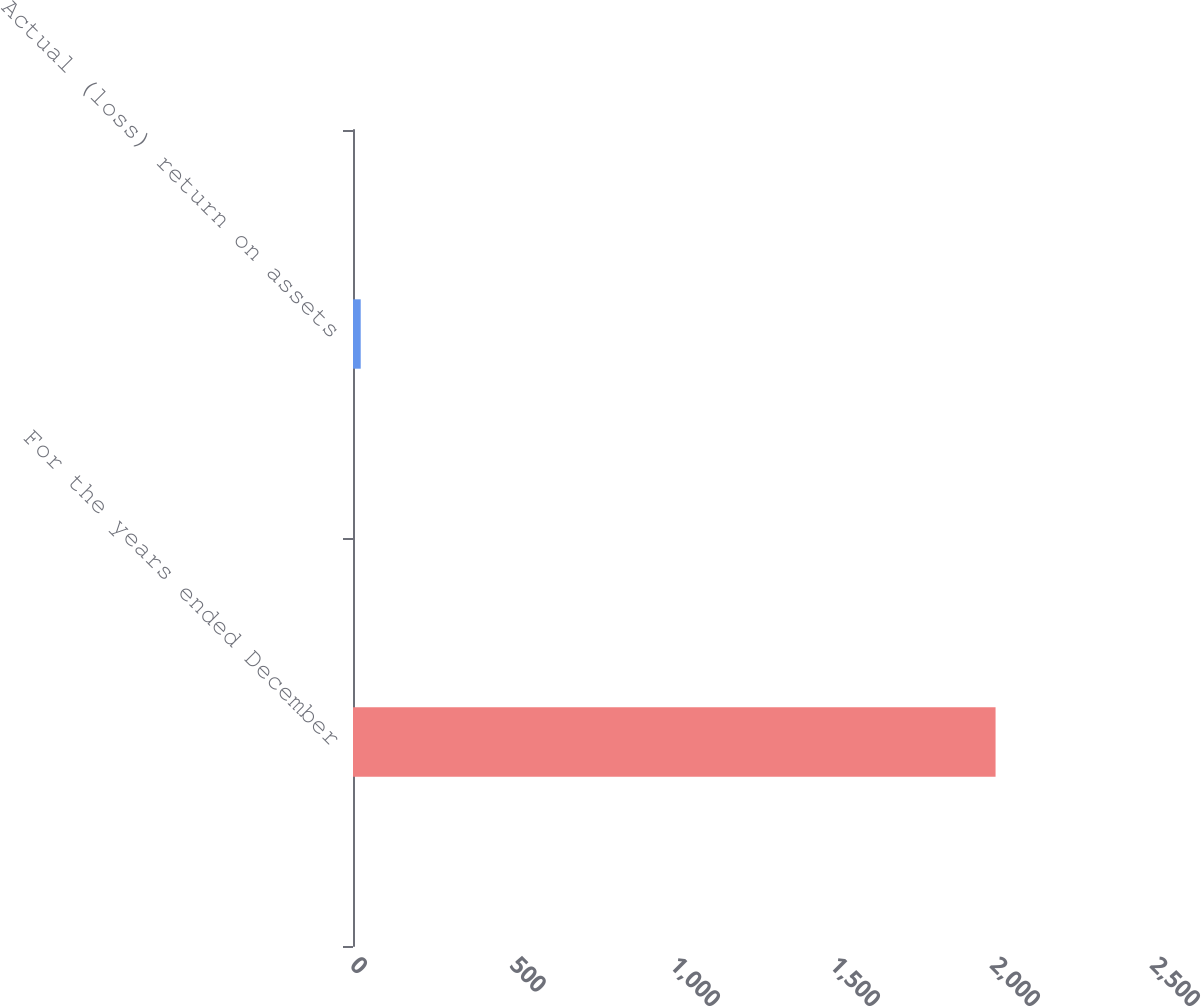Convert chart. <chart><loc_0><loc_0><loc_500><loc_500><bar_chart><fcel>For the years ended December<fcel>Actual (loss) return on assets<nl><fcel>2008<fcel>24.1<nl></chart> 